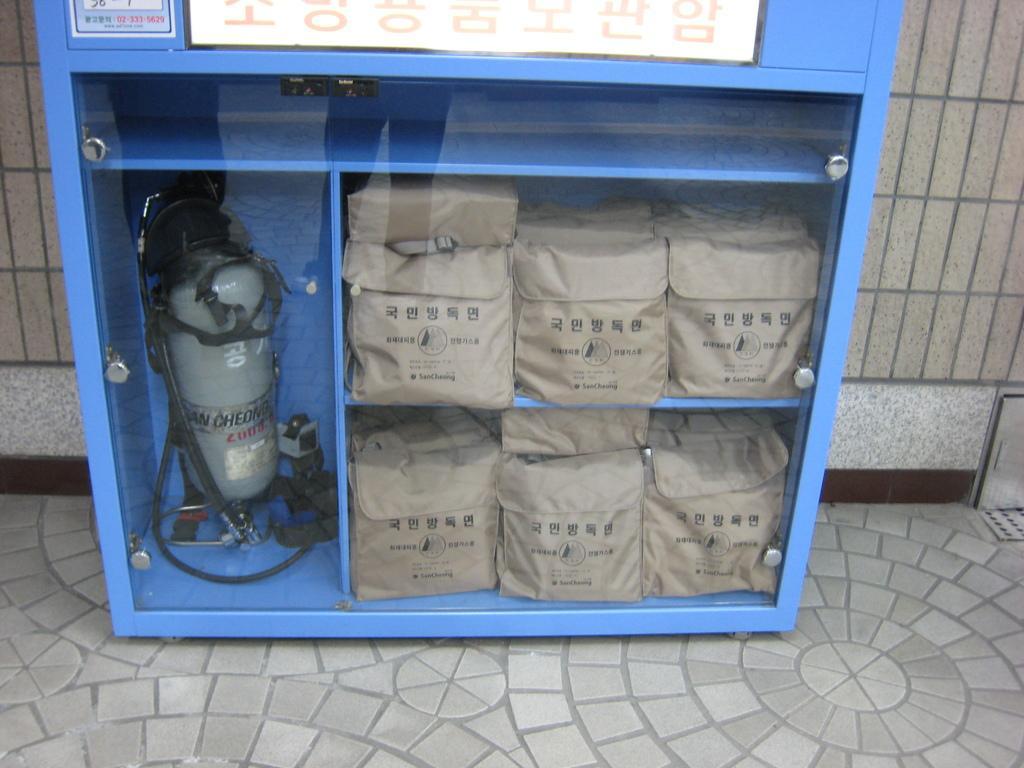Please provide a concise description of this image. In the center of the image there is a cupboard and we can see bags and a cylinder placed in the cupboard. In the background there is a wall. 